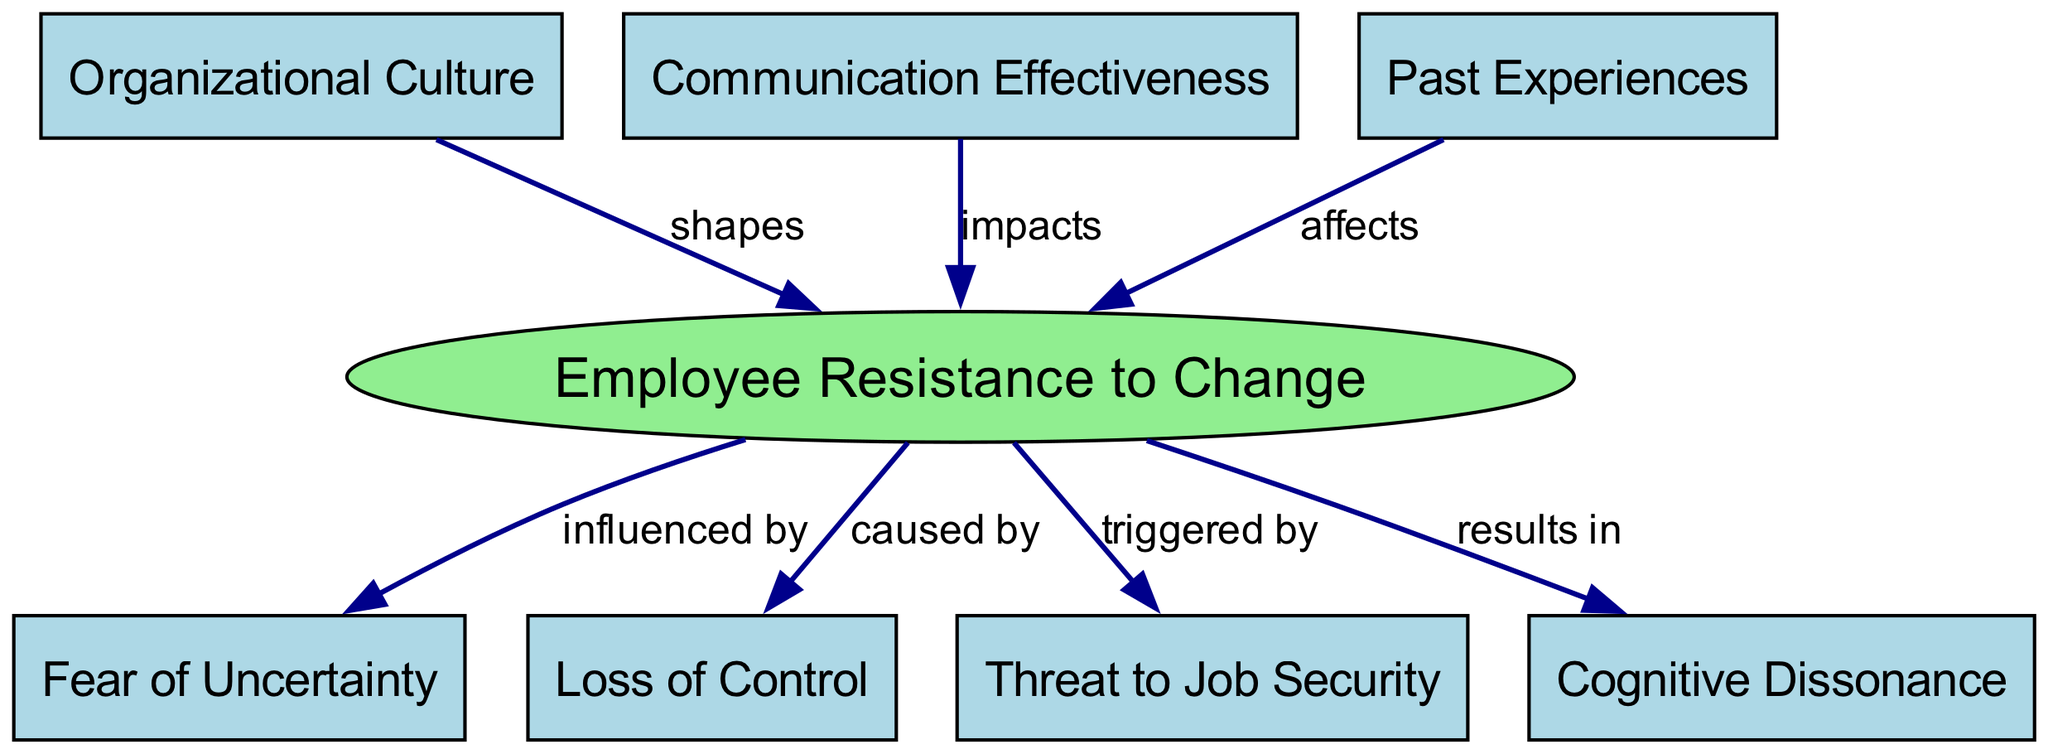What is the main topic of the diagram? The main topic can be identified as "Employee Resistance to Change," which is the central node represented by the ellipse in green. It is clearly distinguished from the other nodes, which relate to different factors influencing this resistance.
Answer: Employee Resistance to Change How many nodes are present in the concept map? By counting all the unique labels in the nodes section, there are a total of eight nodes that represent various psychological and organizational factors related to employee resistance.
Answer: Eight What relationship does "Organizational Culture" have with "Employee Resistance to Change"? The diagram indicates that "Organizational Culture" shapes "Employee Resistance to Change," as shown by the directed edge connecting the two. This relationship is depicted with the label "shapes."
Answer: Shapes Which psychological factor results in cognitive dissonance? The concept map shows that "Employee Resistance to Change" results in "Cognitive Dissonance," indicated by the directed edge labeled "results in" linking the two nodes.
Answer: Cognitive Dissonance How does "Communication Effectiveness" impact employee resistance? The diagram illustrates that "Communication Effectiveness" impacts "Employee Resistance to Change," as represented by a directed edge with the label "impacts" connecting these two nodes, emphasizing the importance of communication during organizational change.
Answer: Impacts What is the relationship between "Fear of Uncertainty" and "Employee Resistance to Change"? "Fear of Uncertainty" is marked as a condition that influences "Employee Resistance to Change," as evidenced by the directed edge labeled "influenced by." This highlights the psychological barrier employees may face when changes occur.
Answer: Influenced by Which factor is triggered by "Employee Resistance to Change"? The diagram shows that "Employee Resistance to Change" triggers the factor "Threat to Job Security," indicated by the directed edge labeled "triggered by," representing a significant concern among employees during change processes.
Answer: Threat to Job Security What influences employee resistance related to past experiences? The concept map shows that "Past Experiences" affects "Employee Resistance to Change," signifying that employees' prior experiences can play a crucial role in how they respond to changes in the organization.
Answer: Affects 